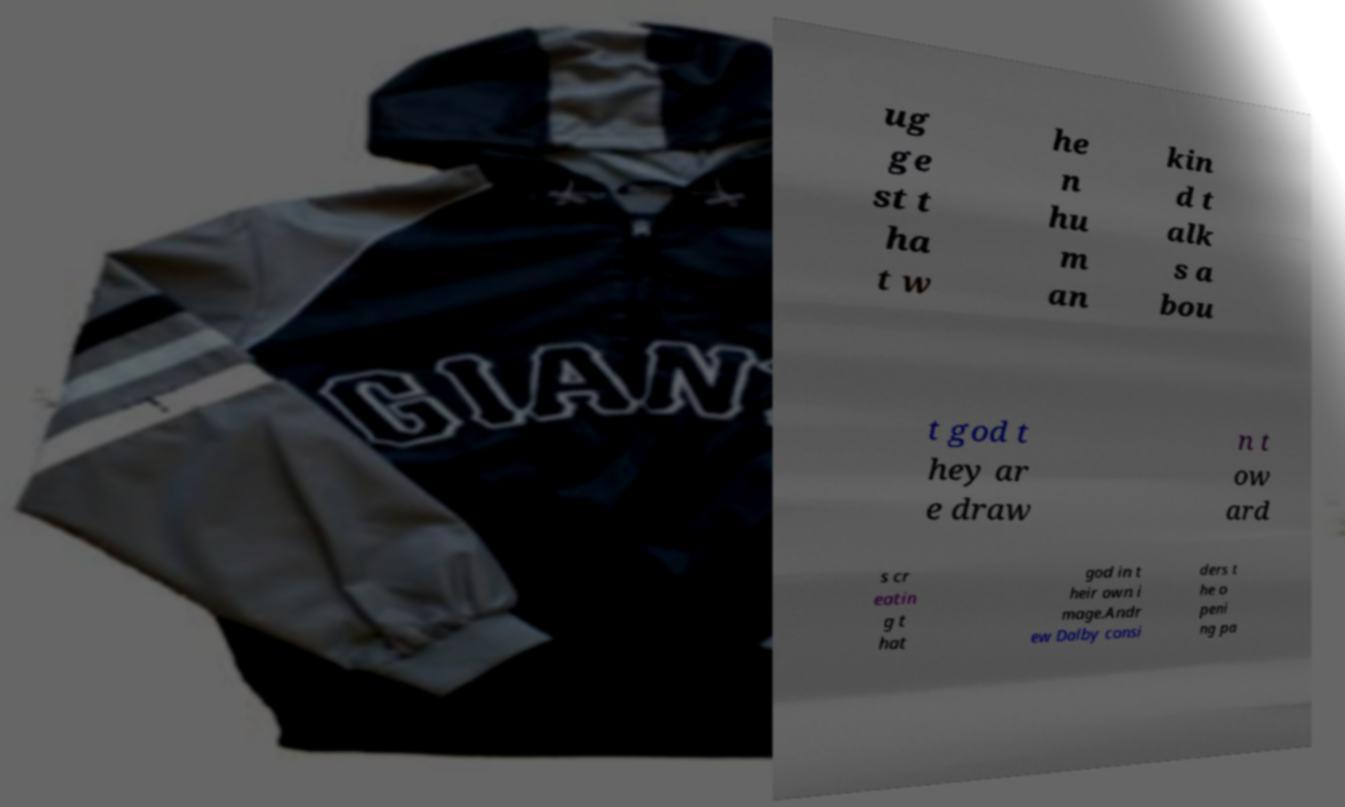Can you read and provide the text displayed in the image?This photo seems to have some interesting text. Can you extract and type it out for me? ug ge st t ha t w he n hu m an kin d t alk s a bou t god t hey ar e draw n t ow ard s cr eatin g t hat god in t heir own i mage.Andr ew Dalby consi ders t he o peni ng pa 